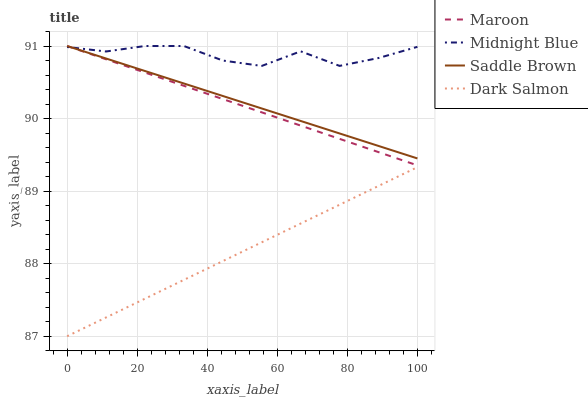Does Dark Salmon have the minimum area under the curve?
Answer yes or no. Yes. Does Midnight Blue have the maximum area under the curve?
Answer yes or no. Yes. Does Maroon have the minimum area under the curve?
Answer yes or no. No. Does Maroon have the maximum area under the curve?
Answer yes or no. No. Is Saddle Brown the smoothest?
Answer yes or no. Yes. Is Midnight Blue the roughest?
Answer yes or no. Yes. Is Maroon the smoothest?
Answer yes or no. No. Is Maroon the roughest?
Answer yes or no. No. Does Dark Salmon have the lowest value?
Answer yes or no. Yes. Does Maroon have the lowest value?
Answer yes or no. No. Does Saddle Brown have the highest value?
Answer yes or no. Yes. Is Dark Salmon less than Midnight Blue?
Answer yes or no. Yes. Is Maroon greater than Dark Salmon?
Answer yes or no. Yes. Does Maroon intersect Saddle Brown?
Answer yes or no. Yes. Is Maroon less than Saddle Brown?
Answer yes or no. No. Is Maroon greater than Saddle Brown?
Answer yes or no. No. Does Dark Salmon intersect Midnight Blue?
Answer yes or no. No. 